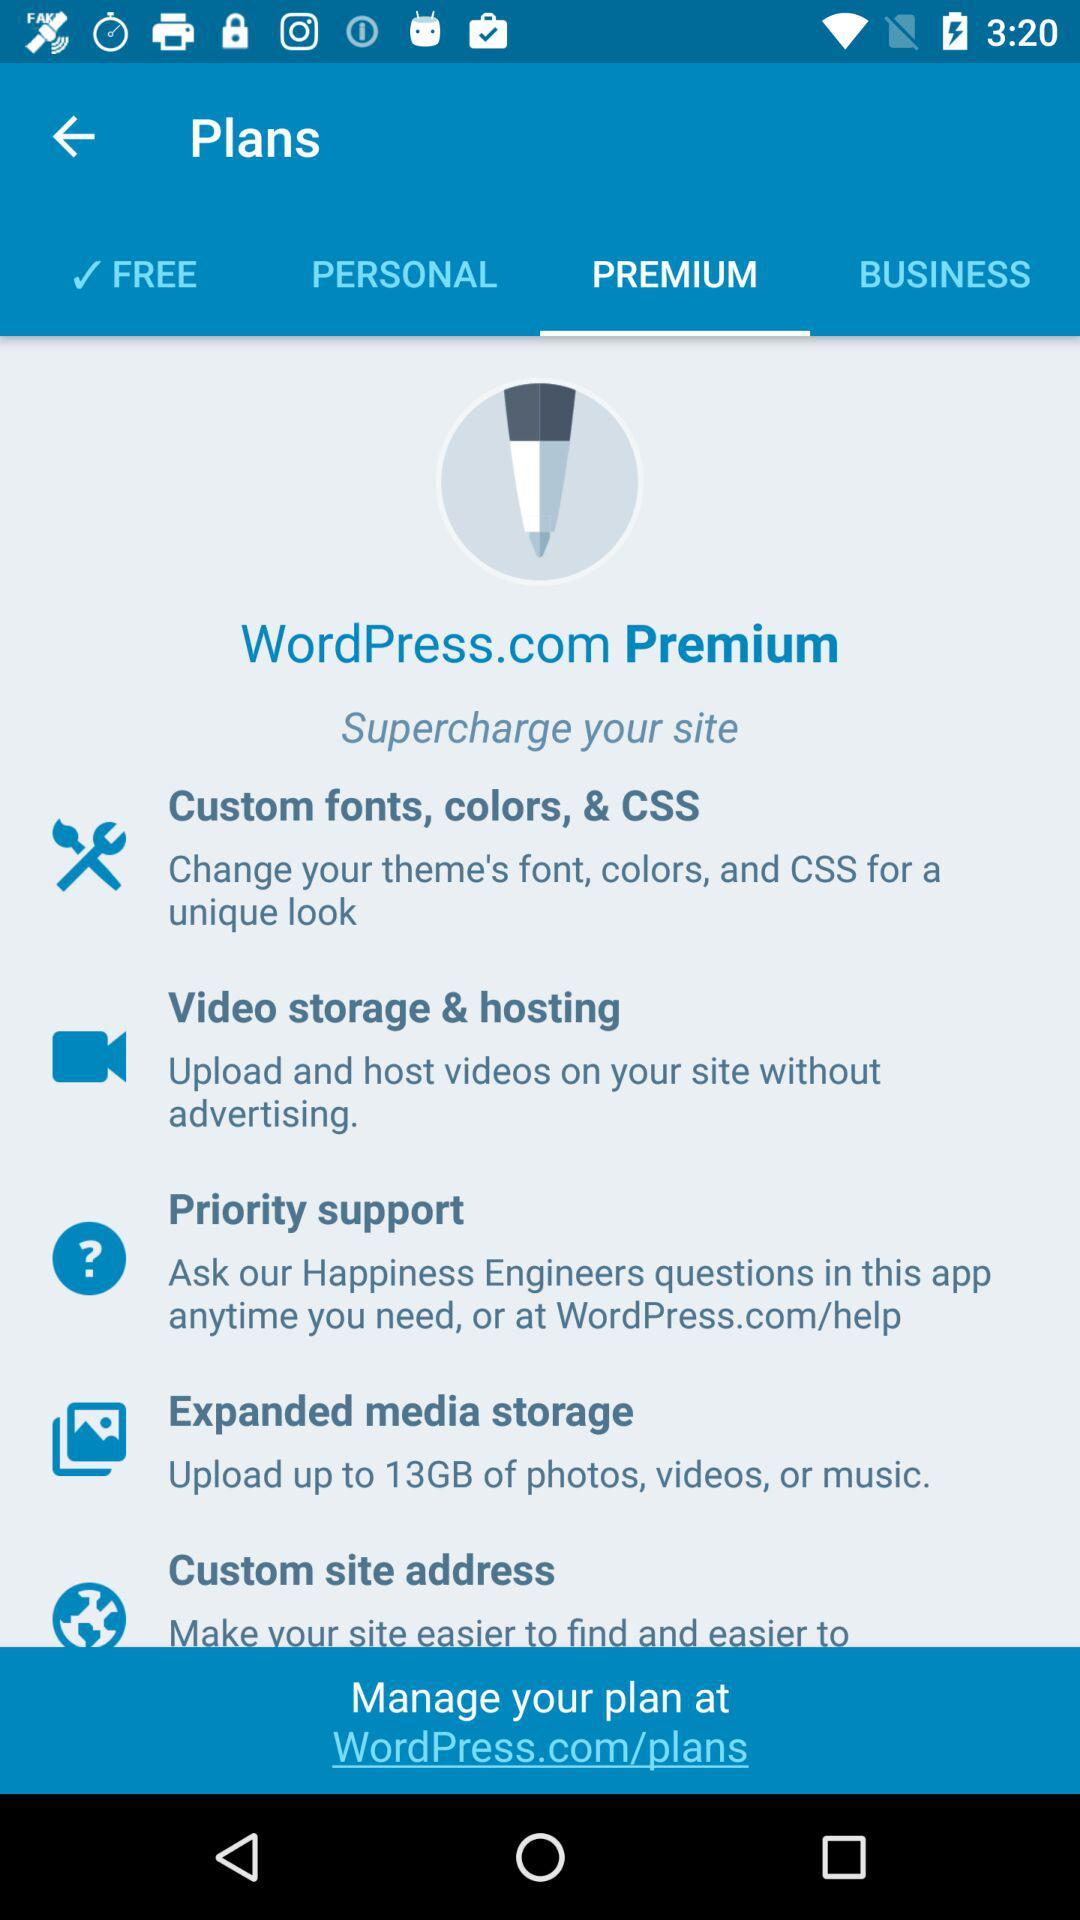What is the size of the expanded media storage? The size is up to 13GB. 